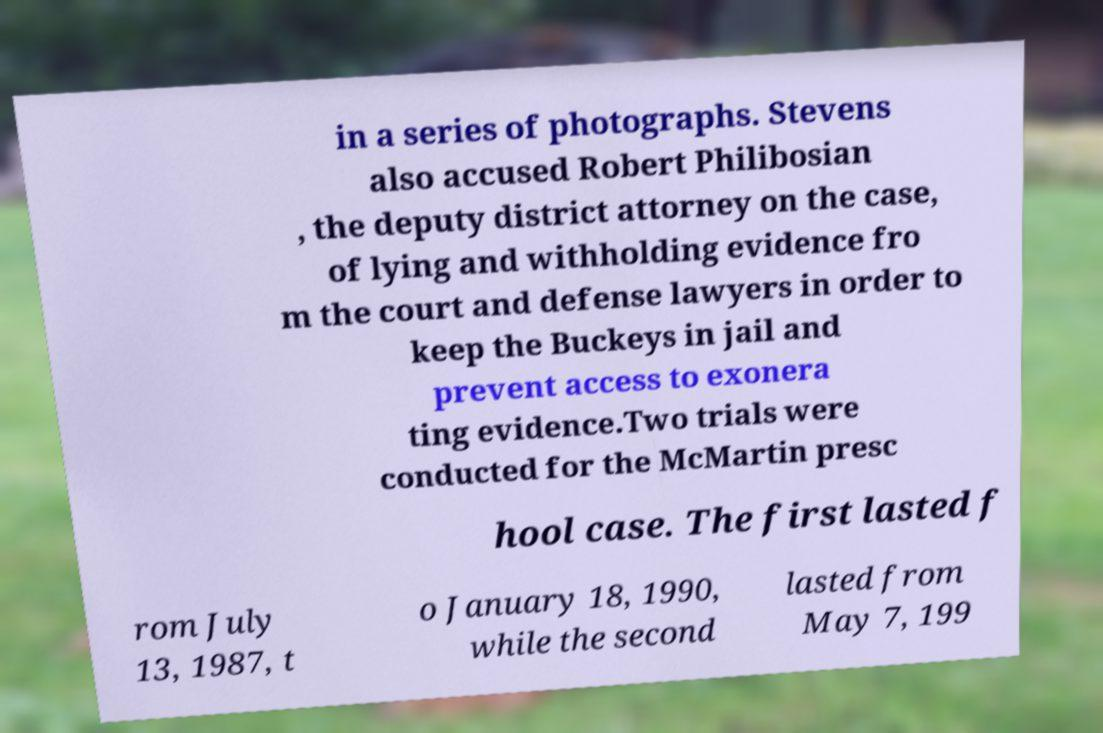Please identify and transcribe the text found in this image. in a series of photographs. Stevens also accused Robert Philibosian , the deputy district attorney on the case, of lying and withholding evidence fro m the court and defense lawyers in order to keep the Buckeys in jail and prevent access to exonera ting evidence.Two trials were conducted for the McMartin presc hool case. The first lasted f rom July 13, 1987, t o January 18, 1990, while the second lasted from May 7, 199 